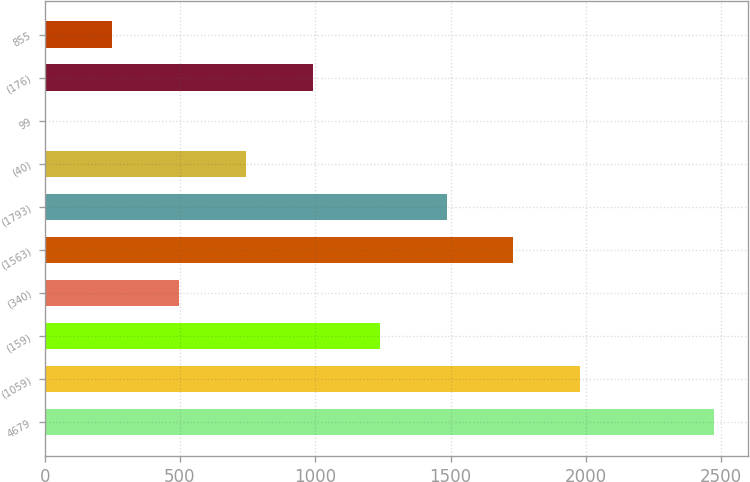Convert chart to OTSL. <chart><loc_0><loc_0><loc_500><loc_500><bar_chart><fcel>4679<fcel>(1059)<fcel>(159)<fcel>(340)<fcel>(1563)<fcel>(1793)<fcel>(40)<fcel>99<fcel>(176)<fcel>855<nl><fcel>2474<fcel>1979.8<fcel>1238.5<fcel>497.2<fcel>1732.7<fcel>1485.6<fcel>744.3<fcel>3<fcel>991.4<fcel>250.1<nl></chart> 